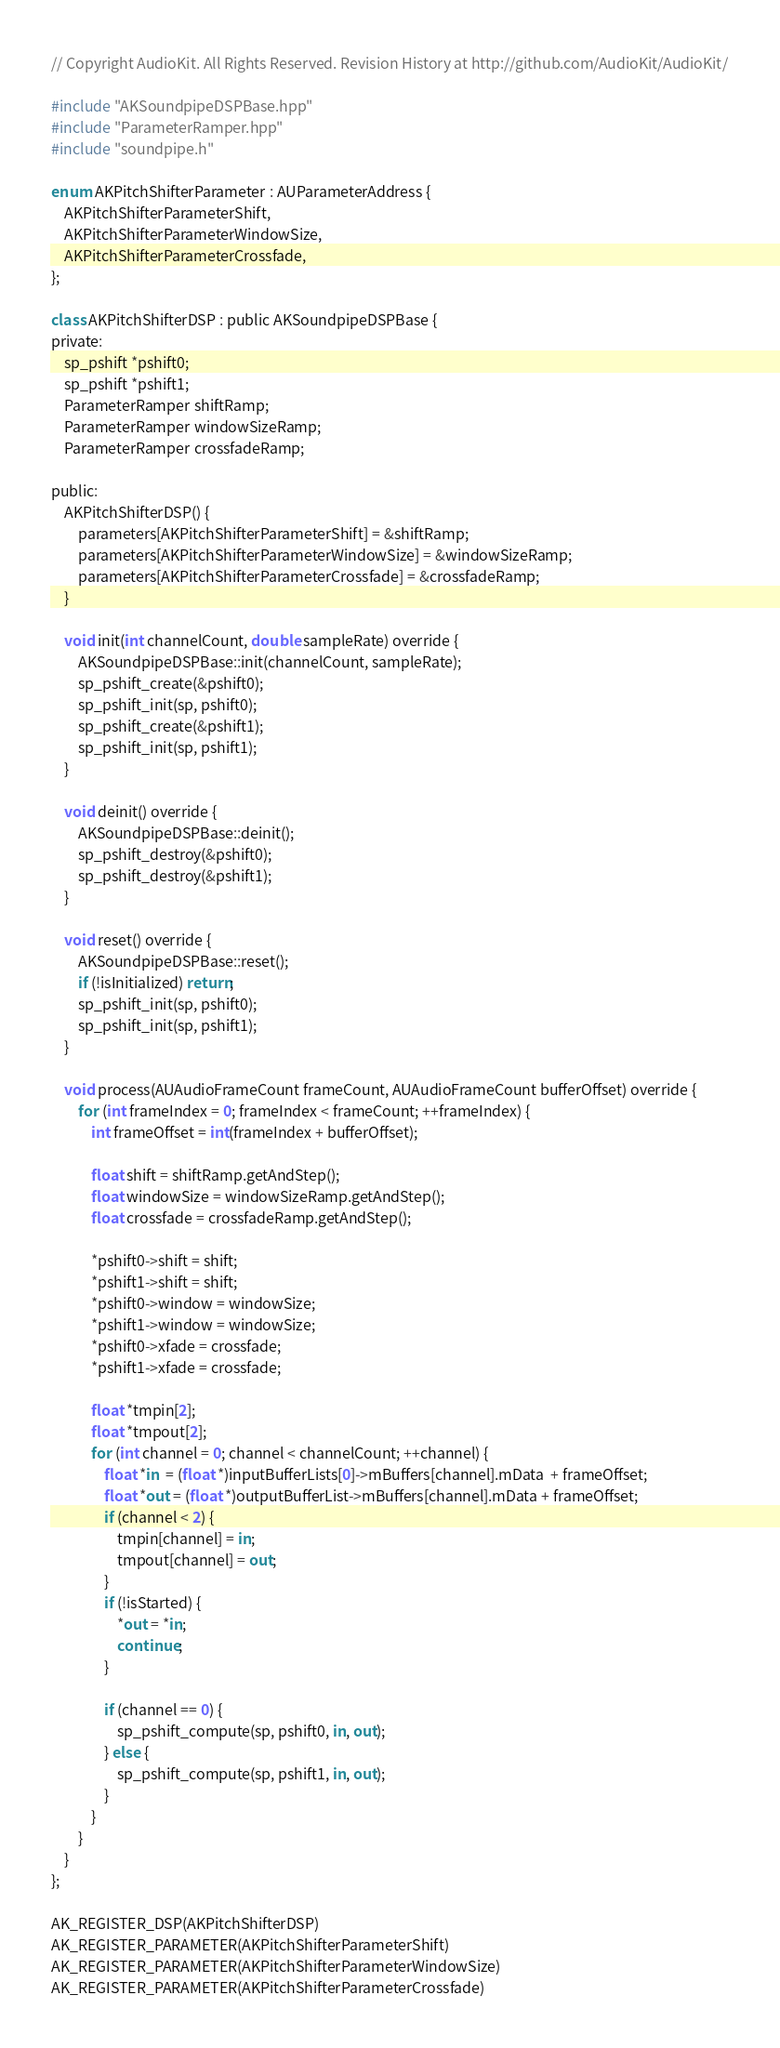<code> <loc_0><loc_0><loc_500><loc_500><_ObjectiveC_>// Copyright AudioKit. All Rights Reserved. Revision History at http://github.com/AudioKit/AudioKit/

#include "AKSoundpipeDSPBase.hpp"
#include "ParameterRamper.hpp"
#include "soundpipe.h"

enum AKPitchShifterParameter : AUParameterAddress {
    AKPitchShifterParameterShift,
    AKPitchShifterParameterWindowSize,
    AKPitchShifterParameterCrossfade,
};

class AKPitchShifterDSP : public AKSoundpipeDSPBase {
private:
    sp_pshift *pshift0;
    sp_pshift *pshift1;
    ParameterRamper shiftRamp;
    ParameterRamper windowSizeRamp;
    ParameterRamper crossfadeRamp;

public:
    AKPitchShifterDSP() {
        parameters[AKPitchShifterParameterShift] = &shiftRamp;
        parameters[AKPitchShifterParameterWindowSize] = &windowSizeRamp;
        parameters[AKPitchShifterParameterCrossfade] = &crossfadeRamp;
    }

    void init(int channelCount, double sampleRate) override {
        AKSoundpipeDSPBase::init(channelCount, sampleRate);
        sp_pshift_create(&pshift0);
        sp_pshift_init(sp, pshift0);
        sp_pshift_create(&pshift1);
        sp_pshift_init(sp, pshift1);
    }

    void deinit() override {
        AKSoundpipeDSPBase::deinit();
        sp_pshift_destroy(&pshift0);
        sp_pshift_destroy(&pshift1);
    }

    void reset() override {
        AKSoundpipeDSPBase::reset();
        if (!isInitialized) return;
        sp_pshift_init(sp, pshift0);
        sp_pshift_init(sp, pshift1);
    }

    void process(AUAudioFrameCount frameCount, AUAudioFrameCount bufferOffset) override {
        for (int frameIndex = 0; frameIndex < frameCount; ++frameIndex) {
            int frameOffset = int(frameIndex + bufferOffset);

            float shift = shiftRamp.getAndStep();
            float windowSize = windowSizeRamp.getAndStep();
            float crossfade = crossfadeRamp.getAndStep();

            *pshift0->shift = shift;
            *pshift1->shift = shift;
            *pshift0->window = windowSize;
            *pshift1->window = windowSize;
            *pshift0->xfade = crossfade;
            *pshift1->xfade = crossfade;

            float *tmpin[2];
            float *tmpout[2];
            for (int channel = 0; channel < channelCount; ++channel) {
                float *in  = (float *)inputBufferLists[0]->mBuffers[channel].mData  + frameOffset;
                float *out = (float *)outputBufferList->mBuffers[channel].mData + frameOffset;
                if (channel < 2) {
                    tmpin[channel] = in;
                    tmpout[channel] = out;
                }
                if (!isStarted) {
                    *out = *in;
                    continue;
                }

                if (channel == 0) {
                    sp_pshift_compute(sp, pshift0, in, out);
                } else {
                    sp_pshift_compute(sp, pshift1, in, out);
                }
            }
        }
    }
};

AK_REGISTER_DSP(AKPitchShifterDSP)
AK_REGISTER_PARAMETER(AKPitchShifterParameterShift)
AK_REGISTER_PARAMETER(AKPitchShifterParameterWindowSize)
AK_REGISTER_PARAMETER(AKPitchShifterParameterCrossfade)
</code> 